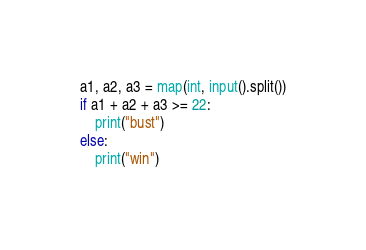<code> <loc_0><loc_0><loc_500><loc_500><_Python_>a1, a2, a3 = map(int, input().split())
if a1 + a2 + a3 >= 22:
    print("bust")
else:
    print("win")
</code> 